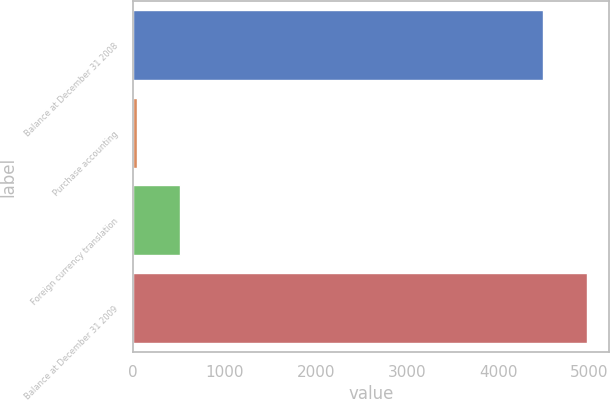Convert chart. <chart><loc_0><loc_0><loc_500><loc_500><bar_chart><fcel>Balance at December 31 2008<fcel>Purchase accounting<fcel>Foreign currency translation<fcel>Balance at December 31 2009<nl><fcel>4492<fcel>39<fcel>515.1<fcel>4968.1<nl></chart> 